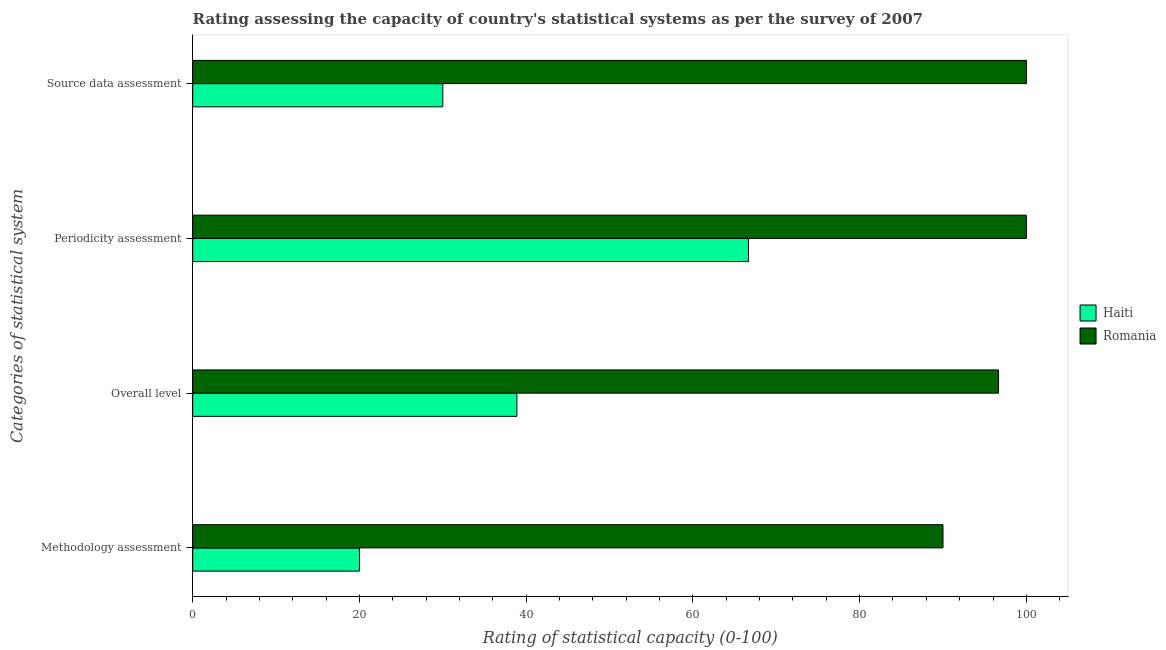Are the number of bars on each tick of the Y-axis equal?
Your answer should be compact. Yes. How many bars are there on the 4th tick from the bottom?
Provide a short and direct response. 2. What is the label of the 3rd group of bars from the top?
Your answer should be very brief. Overall level. What is the methodology assessment rating in Haiti?
Provide a short and direct response. 20. Across all countries, what is the minimum overall level rating?
Provide a succinct answer. 38.89. In which country was the periodicity assessment rating maximum?
Your response must be concise. Romania. In which country was the source data assessment rating minimum?
Make the answer very short. Haiti. What is the total overall level rating in the graph?
Your answer should be compact. 135.56. What is the difference between the periodicity assessment rating in Romania and that in Haiti?
Make the answer very short. 33.33. What is the difference between the methodology assessment rating in Haiti and the periodicity assessment rating in Romania?
Provide a succinct answer. -80. What is the average periodicity assessment rating per country?
Offer a very short reply. 83.33. What is the difference between the source data assessment rating and periodicity assessment rating in Romania?
Offer a very short reply. 0. What is the ratio of the periodicity assessment rating in Haiti to that in Romania?
Offer a very short reply. 0.67. Is the methodology assessment rating in Romania less than that in Haiti?
Your answer should be compact. No. Is the difference between the overall level rating in Haiti and Romania greater than the difference between the periodicity assessment rating in Haiti and Romania?
Your response must be concise. No. What is the difference between the highest and the second highest overall level rating?
Your response must be concise. 57.78. What is the difference between the highest and the lowest overall level rating?
Keep it short and to the point. 57.78. Is the sum of the source data assessment rating in Romania and Haiti greater than the maximum methodology assessment rating across all countries?
Keep it short and to the point. Yes. Is it the case that in every country, the sum of the overall level rating and methodology assessment rating is greater than the sum of periodicity assessment rating and source data assessment rating?
Keep it short and to the point. No. What does the 1st bar from the top in Overall level represents?
Your answer should be compact. Romania. What does the 1st bar from the bottom in Methodology assessment represents?
Keep it short and to the point. Haiti. Is it the case that in every country, the sum of the methodology assessment rating and overall level rating is greater than the periodicity assessment rating?
Give a very brief answer. No. Are all the bars in the graph horizontal?
Provide a short and direct response. Yes. What is the difference between two consecutive major ticks on the X-axis?
Give a very brief answer. 20. What is the title of the graph?
Offer a terse response. Rating assessing the capacity of country's statistical systems as per the survey of 2007 . What is the label or title of the X-axis?
Provide a short and direct response. Rating of statistical capacity (0-100). What is the label or title of the Y-axis?
Offer a terse response. Categories of statistical system. What is the Rating of statistical capacity (0-100) of Haiti in Methodology assessment?
Provide a succinct answer. 20. What is the Rating of statistical capacity (0-100) in Haiti in Overall level?
Provide a succinct answer. 38.89. What is the Rating of statistical capacity (0-100) in Romania in Overall level?
Offer a terse response. 96.67. What is the Rating of statistical capacity (0-100) in Haiti in Periodicity assessment?
Give a very brief answer. 66.67. What is the Rating of statistical capacity (0-100) in Romania in Periodicity assessment?
Provide a succinct answer. 100. What is the Rating of statistical capacity (0-100) of Haiti in Source data assessment?
Make the answer very short. 30. What is the Rating of statistical capacity (0-100) of Romania in Source data assessment?
Offer a terse response. 100. Across all Categories of statistical system, what is the maximum Rating of statistical capacity (0-100) of Haiti?
Offer a terse response. 66.67. Across all Categories of statistical system, what is the minimum Rating of statistical capacity (0-100) of Romania?
Your response must be concise. 90. What is the total Rating of statistical capacity (0-100) in Haiti in the graph?
Ensure brevity in your answer.  155.56. What is the total Rating of statistical capacity (0-100) of Romania in the graph?
Your answer should be very brief. 386.67. What is the difference between the Rating of statistical capacity (0-100) of Haiti in Methodology assessment and that in Overall level?
Give a very brief answer. -18.89. What is the difference between the Rating of statistical capacity (0-100) in Romania in Methodology assessment and that in Overall level?
Your answer should be very brief. -6.67. What is the difference between the Rating of statistical capacity (0-100) of Haiti in Methodology assessment and that in Periodicity assessment?
Offer a very short reply. -46.67. What is the difference between the Rating of statistical capacity (0-100) in Haiti in Overall level and that in Periodicity assessment?
Give a very brief answer. -27.78. What is the difference between the Rating of statistical capacity (0-100) of Romania in Overall level and that in Periodicity assessment?
Provide a short and direct response. -3.33. What is the difference between the Rating of statistical capacity (0-100) in Haiti in Overall level and that in Source data assessment?
Keep it short and to the point. 8.89. What is the difference between the Rating of statistical capacity (0-100) of Haiti in Periodicity assessment and that in Source data assessment?
Your response must be concise. 36.67. What is the difference between the Rating of statistical capacity (0-100) in Romania in Periodicity assessment and that in Source data assessment?
Your answer should be compact. 0. What is the difference between the Rating of statistical capacity (0-100) of Haiti in Methodology assessment and the Rating of statistical capacity (0-100) of Romania in Overall level?
Your answer should be very brief. -76.67. What is the difference between the Rating of statistical capacity (0-100) in Haiti in Methodology assessment and the Rating of statistical capacity (0-100) in Romania in Periodicity assessment?
Offer a terse response. -80. What is the difference between the Rating of statistical capacity (0-100) of Haiti in Methodology assessment and the Rating of statistical capacity (0-100) of Romania in Source data assessment?
Ensure brevity in your answer.  -80. What is the difference between the Rating of statistical capacity (0-100) of Haiti in Overall level and the Rating of statistical capacity (0-100) of Romania in Periodicity assessment?
Offer a very short reply. -61.11. What is the difference between the Rating of statistical capacity (0-100) in Haiti in Overall level and the Rating of statistical capacity (0-100) in Romania in Source data assessment?
Ensure brevity in your answer.  -61.11. What is the difference between the Rating of statistical capacity (0-100) in Haiti in Periodicity assessment and the Rating of statistical capacity (0-100) in Romania in Source data assessment?
Give a very brief answer. -33.33. What is the average Rating of statistical capacity (0-100) of Haiti per Categories of statistical system?
Give a very brief answer. 38.89. What is the average Rating of statistical capacity (0-100) of Romania per Categories of statistical system?
Ensure brevity in your answer.  96.67. What is the difference between the Rating of statistical capacity (0-100) of Haiti and Rating of statistical capacity (0-100) of Romania in Methodology assessment?
Your answer should be compact. -70. What is the difference between the Rating of statistical capacity (0-100) in Haiti and Rating of statistical capacity (0-100) in Romania in Overall level?
Keep it short and to the point. -57.78. What is the difference between the Rating of statistical capacity (0-100) in Haiti and Rating of statistical capacity (0-100) in Romania in Periodicity assessment?
Your answer should be compact. -33.33. What is the difference between the Rating of statistical capacity (0-100) in Haiti and Rating of statistical capacity (0-100) in Romania in Source data assessment?
Your answer should be very brief. -70. What is the ratio of the Rating of statistical capacity (0-100) of Haiti in Methodology assessment to that in Overall level?
Give a very brief answer. 0.51. What is the ratio of the Rating of statistical capacity (0-100) in Romania in Methodology assessment to that in Overall level?
Your answer should be very brief. 0.93. What is the ratio of the Rating of statistical capacity (0-100) in Haiti in Methodology assessment to that in Periodicity assessment?
Offer a very short reply. 0.3. What is the ratio of the Rating of statistical capacity (0-100) in Haiti in Methodology assessment to that in Source data assessment?
Offer a terse response. 0.67. What is the ratio of the Rating of statistical capacity (0-100) of Haiti in Overall level to that in Periodicity assessment?
Offer a very short reply. 0.58. What is the ratio of the Rating of statistical capacity (0-100) in Romania in Overall level to that in Periodicity assessment?
Your answer should be very brief. 0.97. What is the ratio of the Rating of statistical capacity (0-100) of Haiti in Overall level to that in Source data assessment?
Give a very brief answer. 1.3. What is the ratio of the Rating of statistical capacity (0-100) of Romania in Overall level to that in Source data assessment?
Offer a terse response. 0.97. What is the ratio of the Rating of statistical capacity (0-100) in Haiti in Periodicity assessment to that in Source data assessment?
Offer a very short reply. 2.22. What is the difference between the highest and the second highest Rating of statistical capacity (0-100) of Haiti?
Ensure brevity in your answer.  27.78. What is the difference between the highest and the second highest Rating of statistical capacity (0-100) of Romania?
Offer a terse response. 0. What is the difference between the highest and the lowest Rating of statistical capacity (0-100) in Haiti?
Offer a very short reply. 46.67. What is the difference between the highest and the lowest Rating of statistical capacity (0-100) in Romania?
Make the answer very short. 10. 